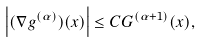Convert formula to latex. <formula><loc_0><loc_0><loc_500><loc_500>\left | ( \nabla g ^ { ( \alpha ) } ) ( x ) \right | \leq C G ^ { ( \alpha + 1 ) } ( x ) ,</formula> 